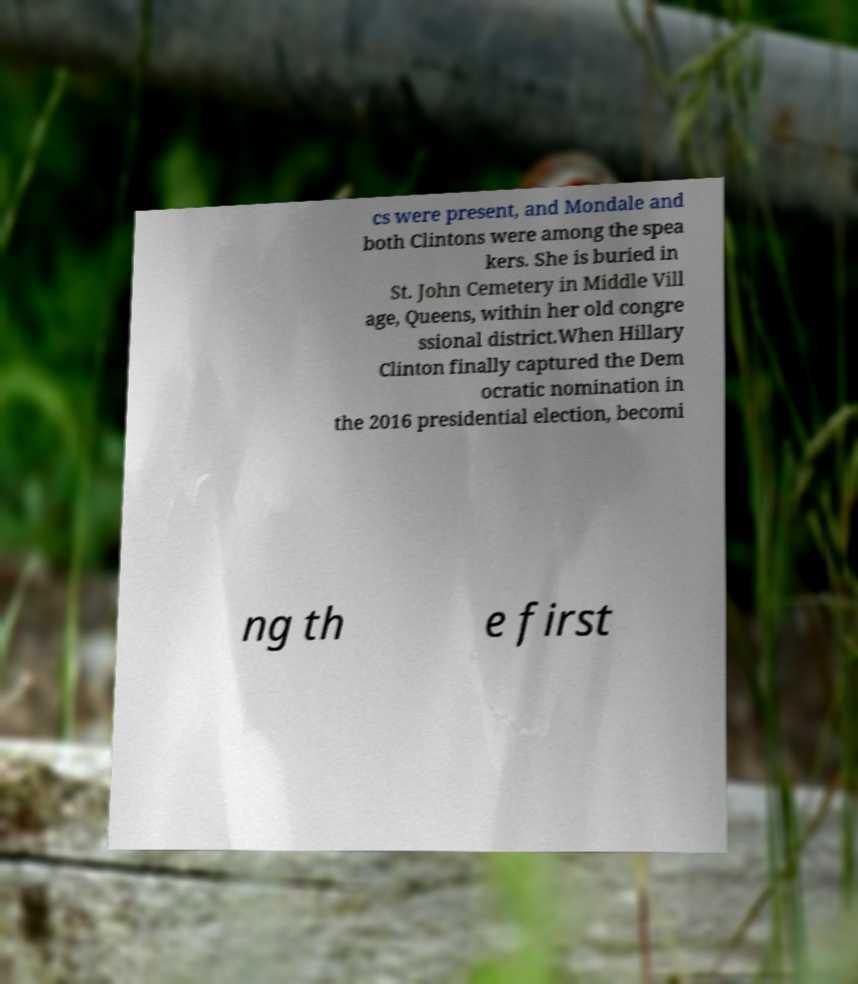Could you assist in decoding the text presented in this image and type it out clearly? cs were present, and Mondale and both Clintons were among the spea kers. She is buried in St. John Cemetery in Middle Vill age, Queens, within her old congre ssional district.When Hillary Clinton finally captured the Dem ocratic nomination in the 2016 presidential election, becomi ng th e first 